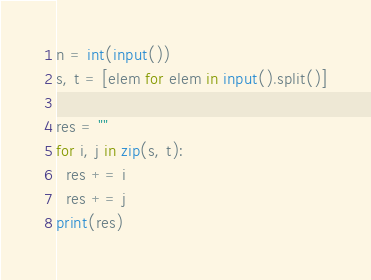<code> <loc_0><loc_0><loc_500><loc_500><_Python_>n = int(input())
s, t = [elem for elem in input().split()]

res = ""
for i, j in zip(s, t):
  res += i
  res += j
print(res)</code> 